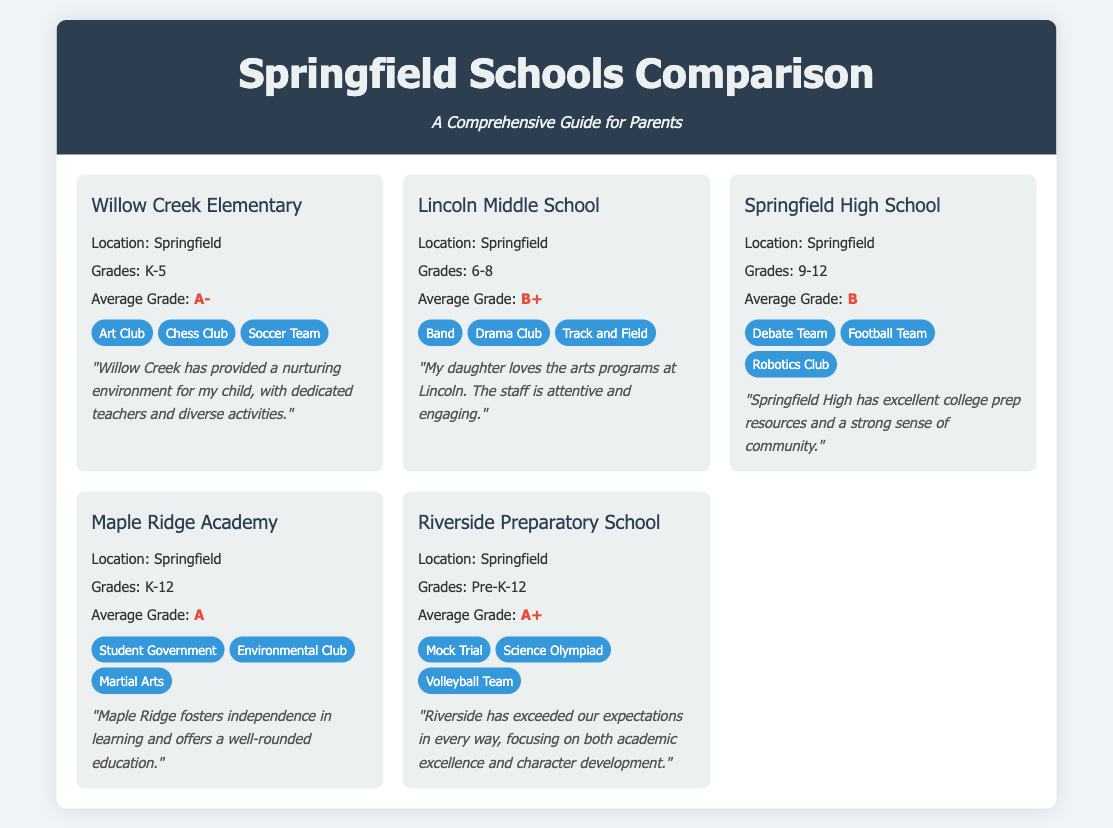What is the average grade of Willow Creek Elementary? The average grade is listed under the school info section for Willow Creek Elementary as A-.
Answer: A- What activities are available at Lincoln Middle School? The activities are displayed under the activities section; they include Band, Drama Club, and Track and Field.
Answer: Band, Drama Club, Track and Field What grades does Springfield High School accommodate? The grades are specified in the school info section, stating that Springfield High School accommodates grades 9-12.
Answer: 9-12 Which school has the highest average grade? The highest average grade can be determined by comparing the average grades of all schools listed; Riverside Preparatory School has an A+.
Answer: A+ What testimonial is given for Maple Ridge Academy? The testimonial is found in the testimonial section for Maple Ridge Academy, which highlights fostering independence in learning and a well-rounded education.
Answer: "Maple Ridge fosters independence in learning and offers a well-rounded education." What is the location of Riverside Preparatory School? The location is provided in the school info section for Riverside Preparatory School, mentioning it is in Springfield.
Answer: Springfield Which school features the activity "Mock Trial"? "Mock Trial" is listed among the activities for Riverside Preparatory School, which identifies it in the document.
Answer: Riverside Preparatory School How many schools are compared in the document? The number of schools can be counted based on the school cards presented; there are five schools compared in total.
Answer: 5 What unique aspect is highlighted for Riverside Preparatory School? The unique aspect is mentioned in the testimonial; it emphasizes a focus on academic excellence and character development.
Answer: Character development What type of document is presented? The document presents a comparative analysis and guide for parents in a school selection context.
Answer: Comparison Guide 